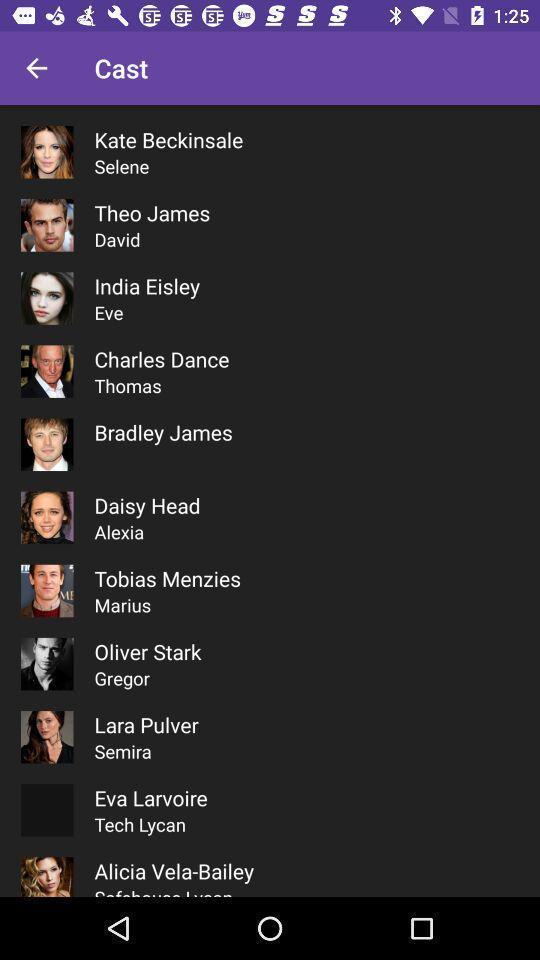Summarize the main components in this picture. Page showing a list of actors. 